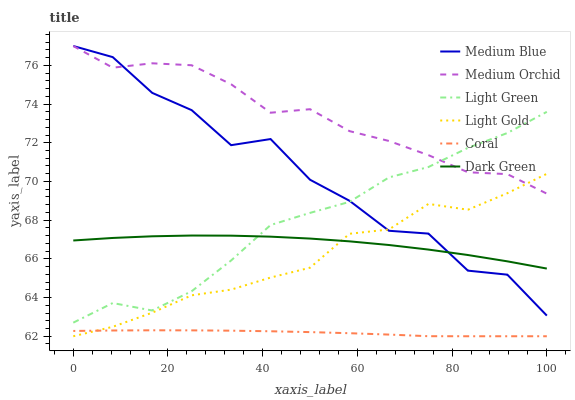Does Coral have the minimum area under the curve?
Answer yes or no. Yes. Does Medium Orchid have the maximum area under the curve?
Answer yes or no. Yes. Does Medium Blue have the minimum area under the curve?
Answer yes or no. No. Does Medium Blue have the maximum area under the curve?
Answer yes or no. No. Is Coral the smoothest?
Answer yes or no. Yes. Is Medium Blue the roughest?
Answer yes or no. Yes. Is Medium Orchid the smoothest?
Answer yes or no. No. Is Medium Orchid the roughest?
Answer yes or no. No. Does Coral have the lowest value?
Answer yes or no. Yes. Does Medium Blue have the lowest value?
Answer yes or no. No. Does Medium Blue have the highest value?
Answer yes or no. Yes. Does Light Green have the highest value?
Answer yes or no. No. Is Coral less than Light Green?
Answer yes or no. Yes. Is Medium Orchid greater than Dark Green?
Answer yes or no. Yes. Does Medium Orchid intersect Light Green?
Answer yes or no. Yes. Is Medium Orchid less than Light Green?
Answer yes or no. No. Is Medium Orchid greater than Light Green?
Answer yes or no. No. Does Coral intersect Light Green?
Answer yes or no. No. 